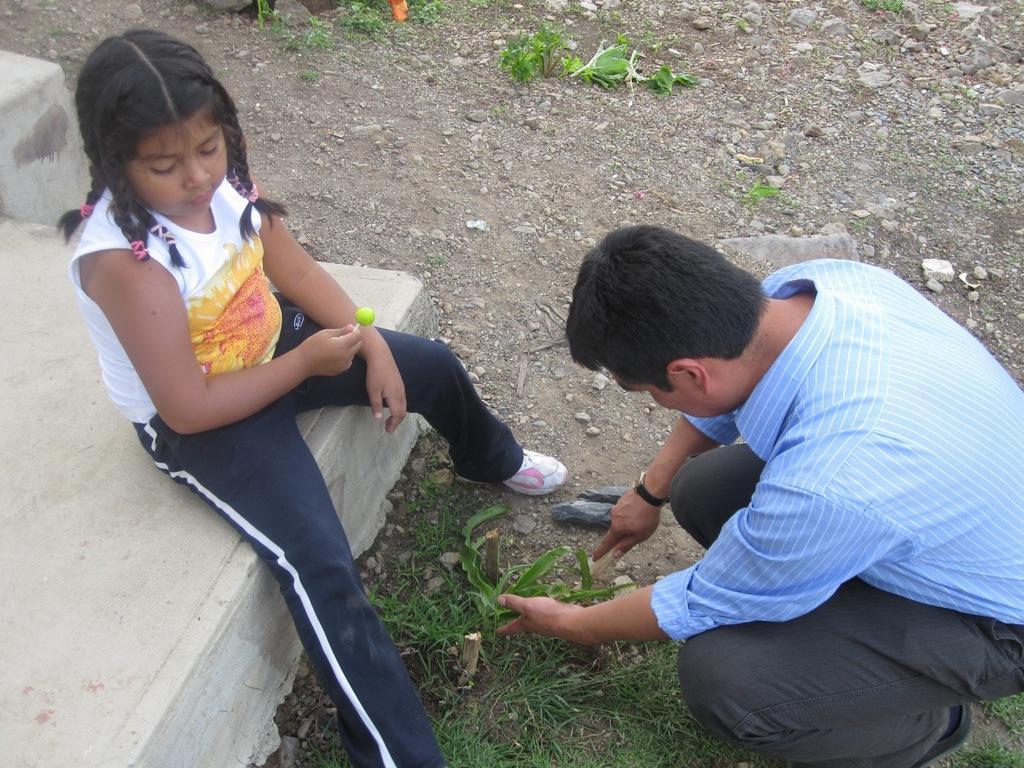Can you describe this image briefly? In the picture I can see a person wearing the blue color shirt is in the squat position and we can see a child wearing white color T-shirt, pant and shoes is holding a lollipop and sitting on the surface. Here we can see grass and stones on the ground. 